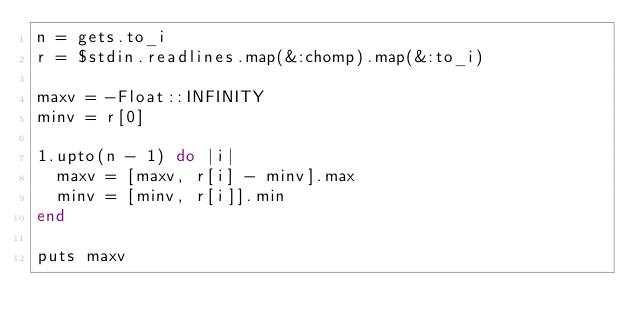<code> <loc_0><loc_0><loc_500><loc_500><_Ruby_>n = gets.to_i
r = $stdin.readlines.map(&:chomp).map(&:to_i)

maxv = -Float::INFINITY
minv = r[0]

1.upto(n - 1) do |i|
  maxv = [maxv, r[i] - minv].max
  minv = [minv, r[i]].min
end

puts maxv</code> 